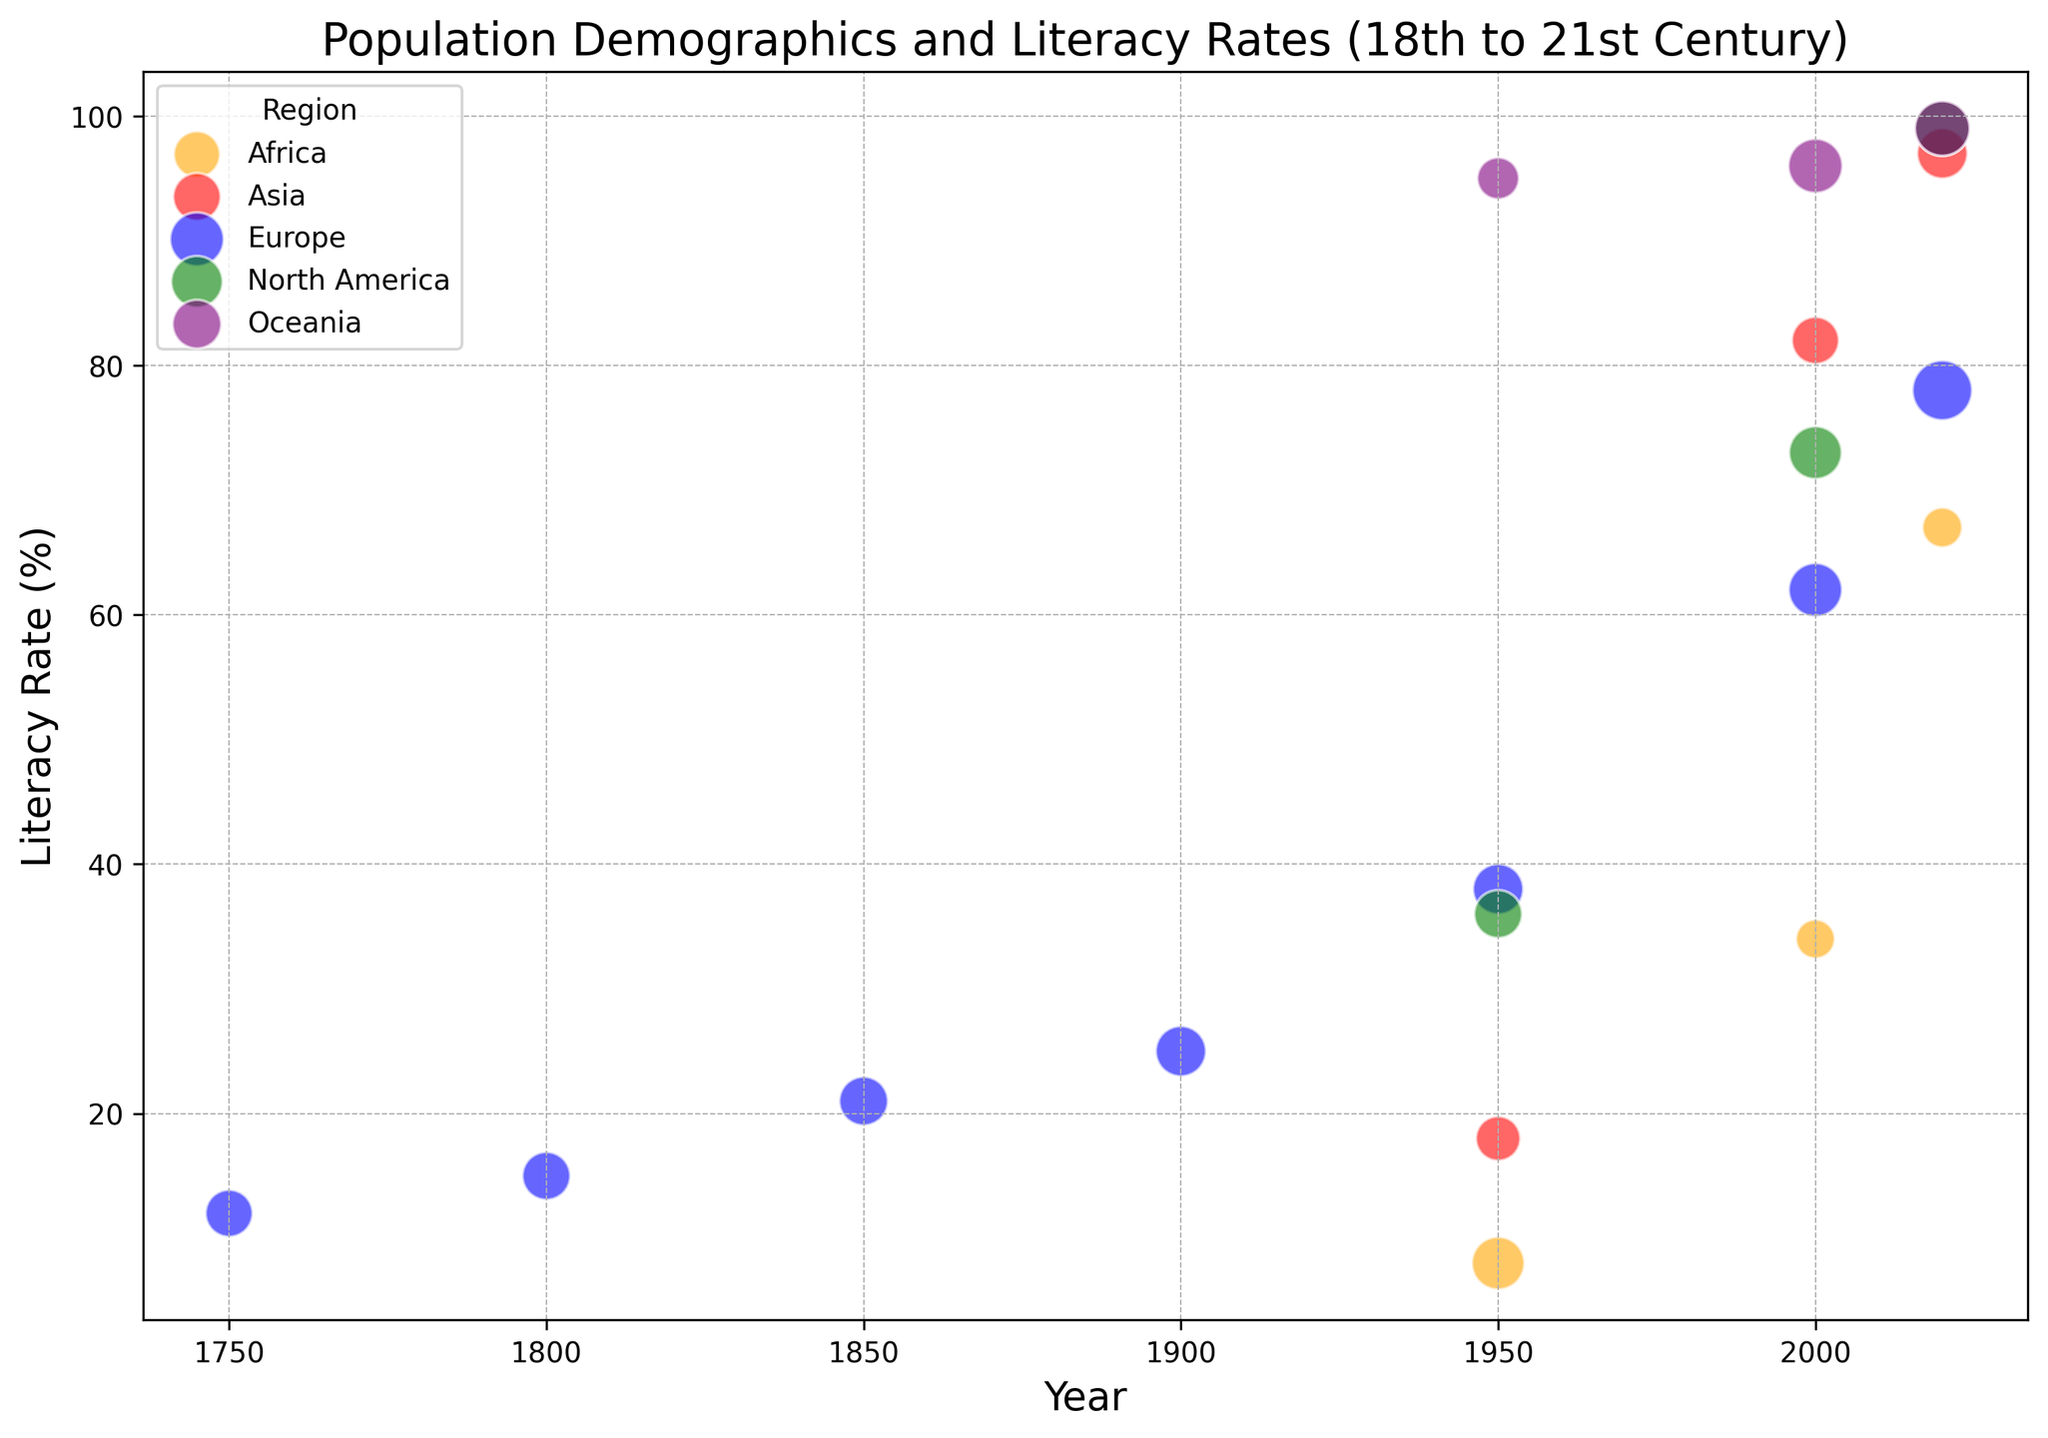What colors represent each region? The figure uses different colors to denote different regions. By checking the legend, we see that Europe is blue, North America is green, Asia is red, Africa is orange, and Oceania is purple.
Answer: Europe: blue, North America: green, Asia: red, Africa: orange, Oceania: purple Which region has the highest literacy rate in 2020? Look at the bubbles on the plot and identify the year 2020. The highest literacy rate bubble in 2020 is colored purple, which represents Oceania.
Answer: Oceania Compare the literacy rates of Europe and Asia in the year 2000. Which region has a higher literacy rate and by how much? Locate the bubbles corresponding to Europe and Asia in the year 2000. Europe has a literacy rate of 62%, and Asia has a literacy rate of 82%. The difference is 82% - 62% = 20%.
Answer: Asia, by 20% How has the population of North America changed between 1950 and 2020? Check the bubbles for North America in 1950 and 2020. The population in 1950 is 2.52 billion, and in 2020 it is 7.79 billion. So, the change is 7.79 billion - 2.52 billion = 5.27 billion.
Answer: Increased by 5.27 billion Which region had the highest average age in 2020, and what was it? On the graph, find the bubbles for the year 2020 and look at the sizes of the bubbles. The largest bubble represents Europe with an average age of 45.
Answer: Europe, 45 Between 1750 and 1850, how did the literacy rate in Europe change? Focus on the bubbles for Europe from 1750 to 1850. The literacy rate in 1750 was 12%, and by 1850, it increased to 21%. The change is 21% - 12% = 9%.
Answer: Increased by 9% Comparing 1950 and 2000, how did the literacy rates in Africa change? Look at the bubbles for Africa in 1950 and 2000. The literacy rate in 1950 was 8%, and by 2000 it was 34%. The change is 34% - 8% = 26%.
Answer: Increased by 26% In which year did Oceania have the highest literacy rate, and what was the rate? Examine the bubbles for Oceania and look for the highest point on the Y-axis. Both in 2000 and 2020, Oceania had a literacy rate of 96% and 99%, respectively. The highest is in 2020 with 99%.
Answer: 2020, 99% Visualize the population sizes of Europe in 1750 and 2020. In which year was the population larger and by how much? Compare the sizes of the bubbles for Europe in 1750 and 2020. The population in 1750 was 0.79 billion and in 2020 it was 0.75 billion. The population was larger in 1750 by 0.04 billion.
Answer: 1750, by 0.04 billion 